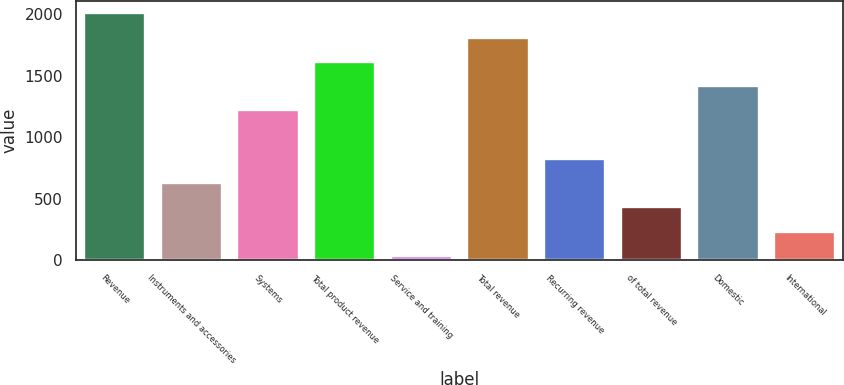Convert chart to OTSL. <chart><loc_0><loc_0><loc_500><loc_500><bar_chart><fcel>Revenue<fcel>Instruments and accessories<fcel>Systems<fcel>Total product revenue<fcel>Service and training<fcel>Total revenue<fcel>Recurring revenue<fcel>of total revenue<fcel>Domestic<fcel>International<nl><fcel>2005<fcel>625.93<fcel>1216.96<fcel>1610.98<fcel>34.9<fcel>1807.99<fcel>822.94<fcel>428.92<fcel>1413.97<fcel>231.91<nl></chart> 